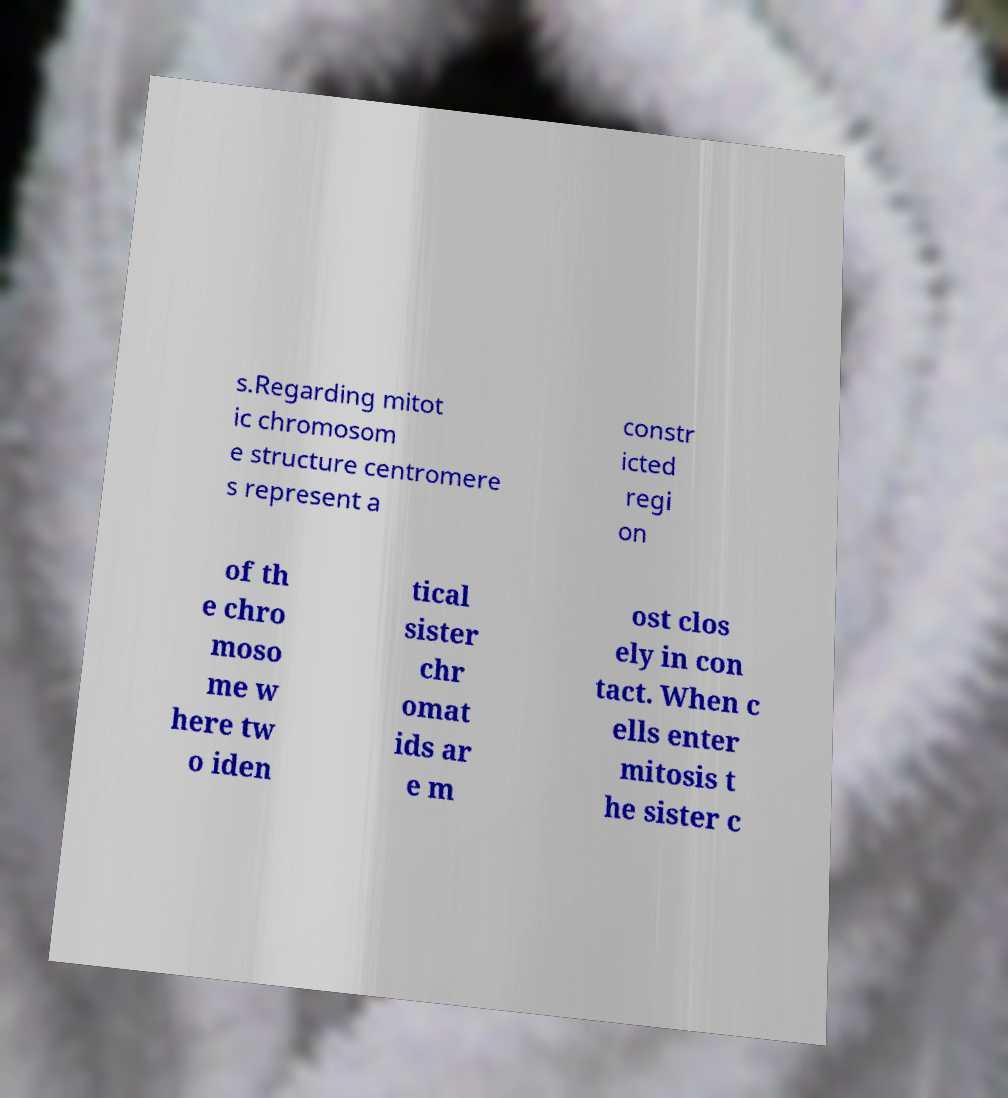For documentation purposes, I need the text within this image transcribed. Could you provide that? s.Regarding mitot ic chromosom e structure centromere s represent a constr icted regi on of th e chro moso me w here tw o iden tical sister chr omat ids ar e m ost clos ely in con tact. When c ells enter mitosis t he sister c 